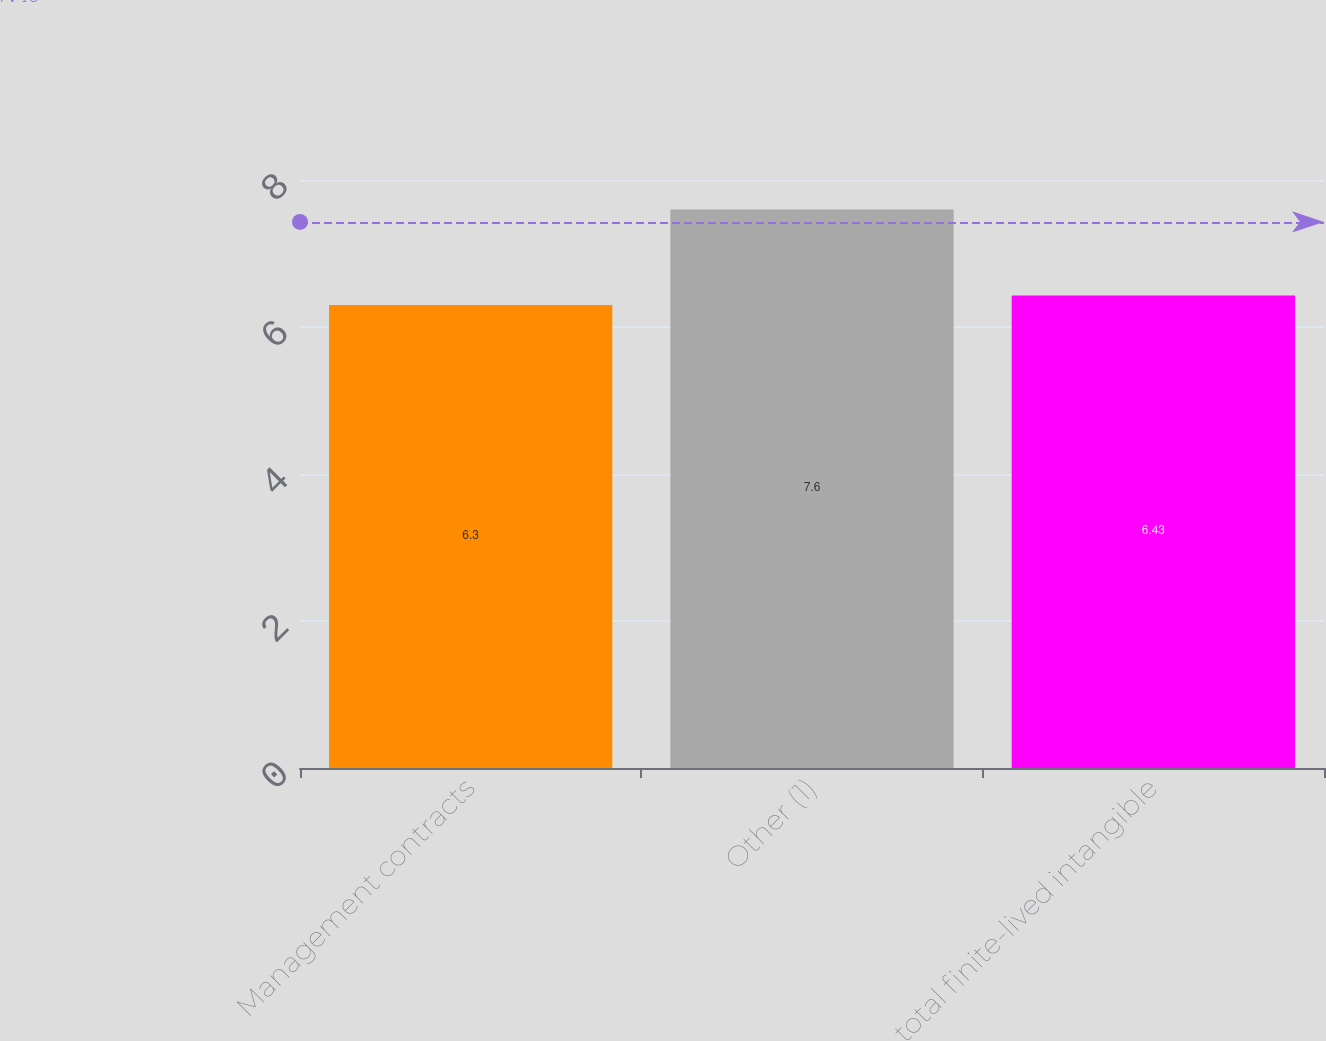Convert chart to OTSL. <chart><loc_0><loc_0><loc_500><loc_500><bar_chart><fcel>Management contracts<fcel>Other (1)<fcel>total finite-lived intangible<nl><fcel>6.3<fcel>7.6<fcel>6.43<nl></chart> 